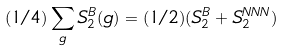<formula> <loc_0><loc_0><loc_500><loc_500>( 1 / 4 ) \sum _ { g } S _ { 2 } ^ { B } ( g ) = ( 1 / 2 ) ( S _ { 2 } ^ { B } + S _ { 2 } ^ { N N N } )</formula> 